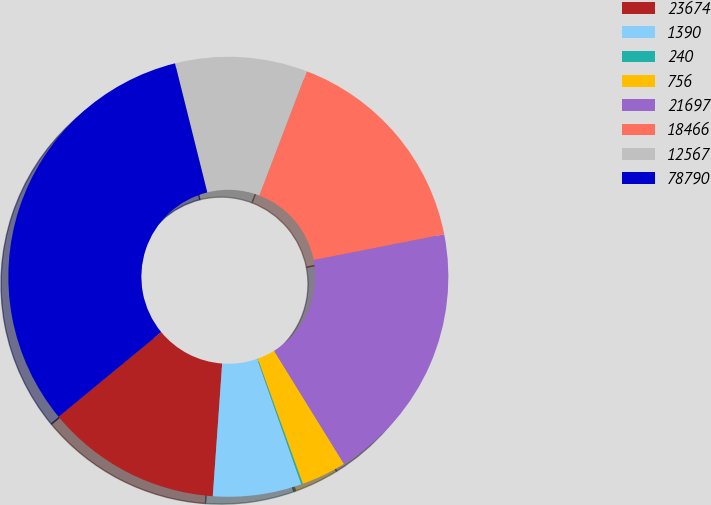Convert chart to OTSL. <chart><loc_0><loc_0><loc_500><loc_500><pie_chart><fcel>23674<fcel>1390<fcel>240<fcel>756<fcel>21697<fcel>18466<fcel>12567<fcel>78790<nl><fcel>12.9%<fcel>6.51%<fcel>0.12%<fcel>3.31%<fcel>19.29%<fcel>16.1%<fcel>9.7%<fcel>32.08%<nl></chart> 